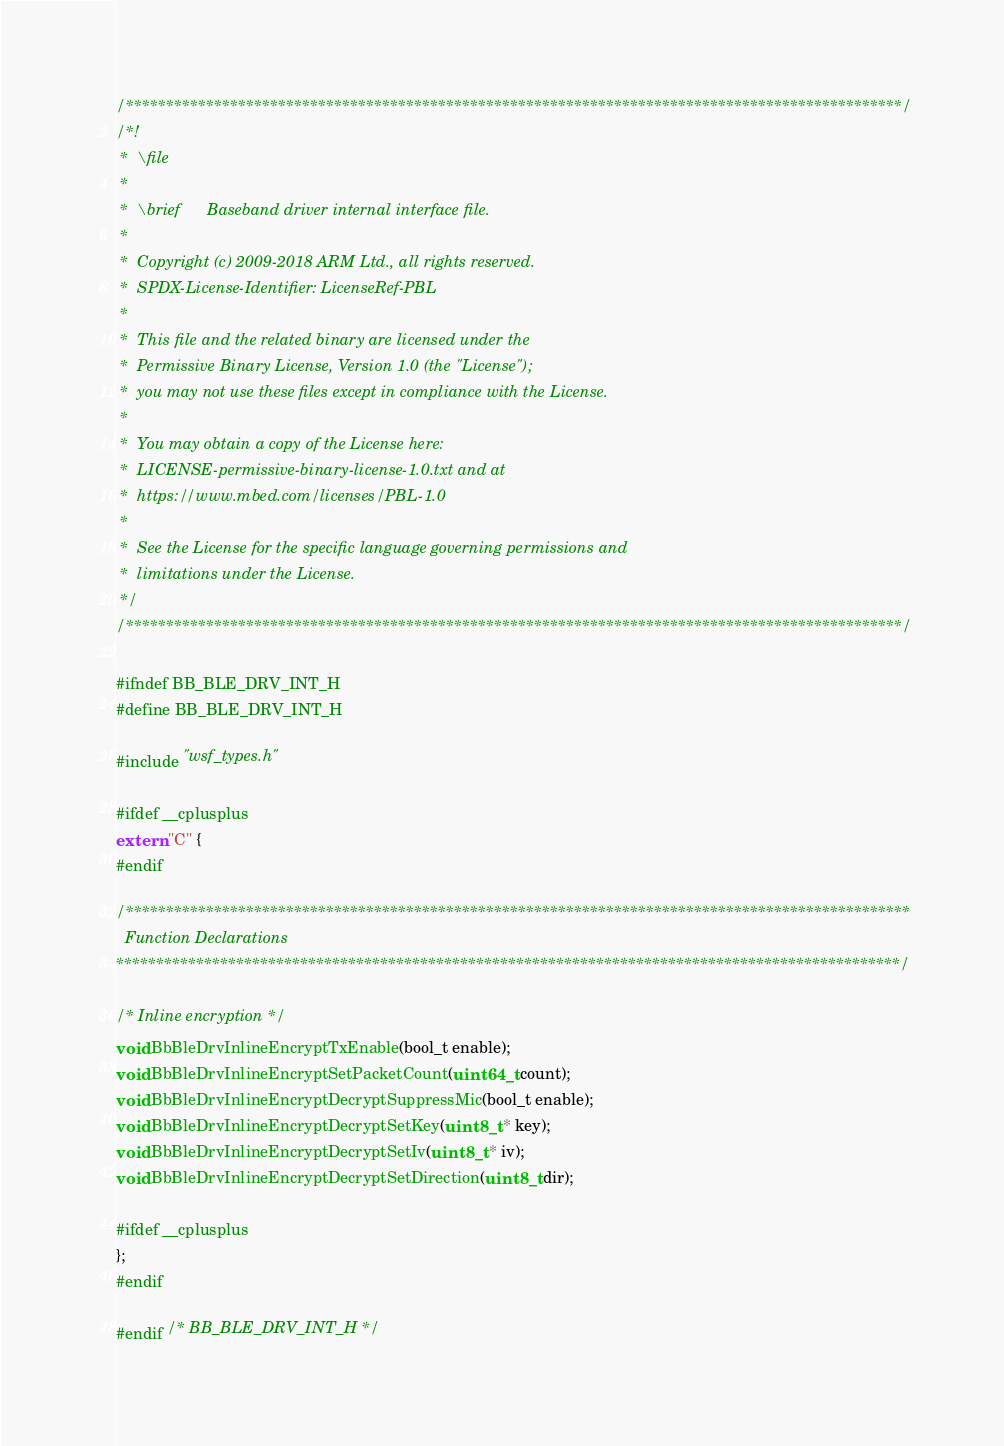Convert code to text. <code><loc_0><loc_0><loc_500><loc_500><_C_>/*************************************************************************************************/
/*!
 *  \file
 *
 *  \brief      Baseband driver internal interface file.
 *
 *  Copyright (c) 2009-2018 ARM Ltd., all rights reserved.
 *  SPDX-License-Identifier: LicenseRef-PBL
 *
 *  This file and the related binary are licensed under the
 *  Permissive Binary License, Version 1.0 (the "License");
 *  you may not use these files except in compliance with the License.
 *
 *  You may obtain a copy of the License here:
 *  LICENSE-permissive-binary-license-1.0.txt and at
 *  https://www.mbed.com/licenses/PBL-1.0
 *
 *  See the License for the specific language governing permissions and
 *  limitations under the License.
 */
/*************************************************************************************************/

#ifndef BB_BLE_DRV_INT_H
#define BB_BLE_DRV_INT_H

#include "wsf_types.h"

#ifdef __cplusplus
extern "C" {
#endif

/**************************************************************************************************
  Function Declarations
**************************************************************************************************/

/* Inline encryption */
void BbBleDrvInlineEncryptTxEnable(bool_t enable);
void BbBleDrvInlineEncryptSetPacketCount(uint64_t count);
void BbBleDrvInlineEncryptDecryptSuppressMic(bool_t enable);
void BbBleDrvInlineEncryptDecryptSetKey(uint8_t * key);
void BbBleDrvInlineEncryptDecryptSetIv(uint8_t * iv);
void BbBleDrvInlineEncryptDecryptSetDirection(uint8_t dir);

#ifdef __cplusplus
};
#endif

#endif /* BB_BLE_DRV_INT_H */
</code> 